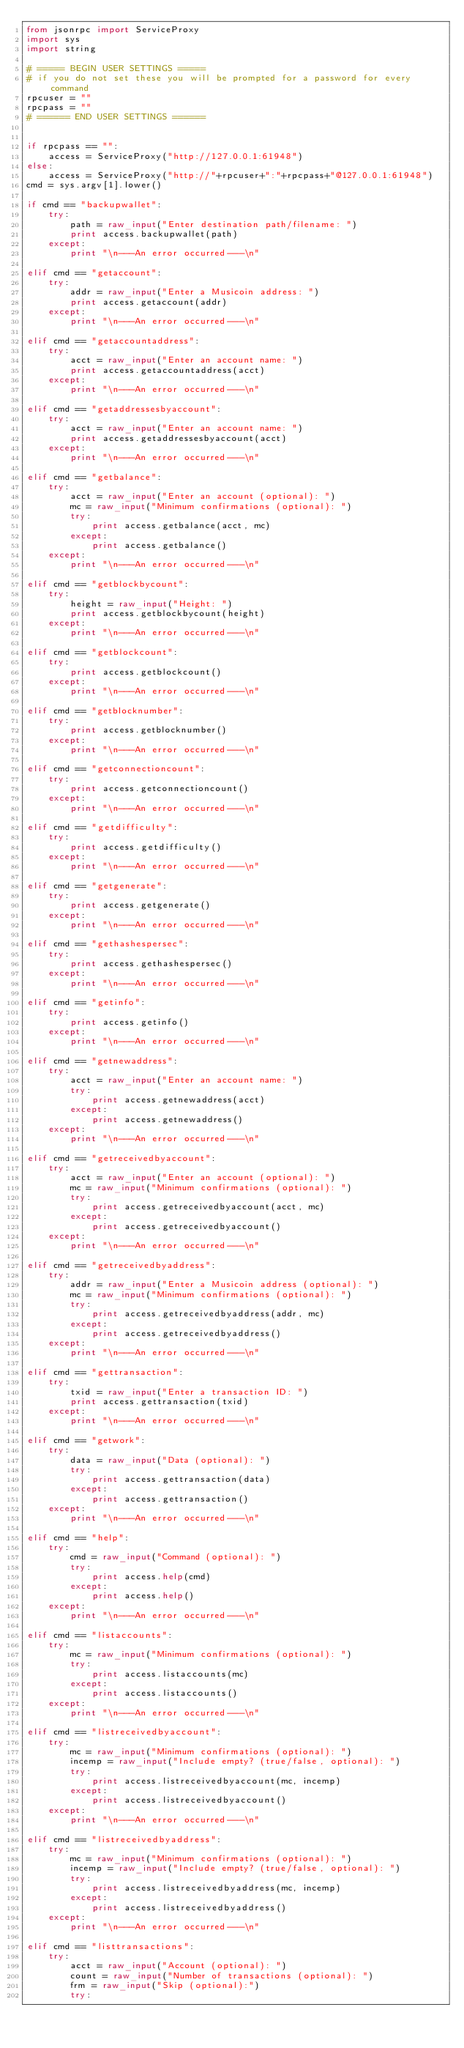Convert code to text. <code><loc_0><loc_0><loc_500><loc_500><_Python_>from jsonrpc import ServiceProxy
import sys
import string

# ===== BEGIN USER SETTINGS =====
# if you do not set these you will be prompted for a password for every command
rpcuser = ""
rpcpass = ""
# ====== END USER SETTINGS ======


if rpcpass == "":
	access = ServiceProxy("http://127.0.0.1:61948")
else:
	access = ServiceProxy("http://"+rpcuser+":"+rpcpass+"@127.0.0.1:61948")
cmd = sys.argv[1].lower()

if cmd == "backupwallet":
	try:
		path = raw_input("Enter destination path/filename: ")
		print access.backupwallet(path)
	except:
		print "\n---An error occurred---\n"

elif cmd == "getaccount":
	try:
		addr = raw_input("Enter a Musicoin address: ")
		print access.getaccount(addr)
	except:
		print "\n---An error occurred---\n"

elif cmd == "getaccountaddress":
	try:
		acct = raw_input("Enter an account name: ")
		print access.getaccountaddress(acct)
	except:
		print "\n---An error occurred---\n"

elif cmd == "getaddressesbyaccount":
	try:
		acct = raw_input("Enter an account name: ")
		print access.getaddressesbyaccount(acct)
	except:
		print "\n---An error occurred---\n"

elif cmd == "getbalance":
	try:
		acct = raw_input("Enter an account (optional): ")
		mc = raw_input("Minimum confirmations (optional): ")
		try:
			print access.getbalance(acct, mc)
		except:
			print access.getbalance()
	except:
		print "\n---An error occurred---\n"

elif cmd == "getblockbycount":
	try:
		height = raw_input("Height: ")
		print access.getblockbycount(height)
	except:
		print "\n---An error occurred---\n"

elif cmd == "getblockcount":
	try:
		print access.getblockcount()
	except:
		print "\n---An error occurred---\n"

elif cmd == "getblocknumber":
	try:
		print access.getblocknumber()
	except:
		print "\n---An error occurred---\n"

elif cmd == "getconnectioncount":
	try:
		print access.getconnectioncount()
	except:
		print "\n---An error occurred---\n"

elif cmd == "getdifficulty":
	try:
		print access.getdifficulty()
	except:
		print "\n---An error occurred---\n"

elif cmd == "getgenerate":
	try:
		print access.getgenerate()
	except:
		print "\n---An error occurred---\n"

elif cmd == "gethashespersec":
	try:
		print access.gethashespersec()
	except:
		print "\n---An error occurred---\n"

elif cmd == "getinfo":
	try:
		print access.getinfo()
	except:
		print "\n---An error occurred---\n"

elif cmd == "getnewaddress":
	try:
		acct = raw_input("Enter an account name: ")
		try:
			print access.getnewaddress(acct)
		except:
			print access.getnewaddress()
	except:
		print "\n---An error occurred---\n"

elif cmd == "getreceivedbyaccount":
	try:
		acct = raw_input("Enter an account (optional): ")
		mc = raw_input("Minimum confirmations (optional): ")
		try:
			print access.getreceivedbyaccount(acct, mc)
		except:
			print access.getreceivedbyaccount()
	except:
		print "\n---An error occurred---\n"

elif cmd == "getreceivedbyaddress":
	try:
		addr = raw_input("Enter a Musicoin address (optional): ")
		mc = raw_input("Minimum confirmations (optional): ")
		try:
			print access.getreceivedbyaddress(addr, mc)
		except:
			print access.getreceivedbyaddress()
	except:
		print "\n---An error occurred---\n"

elif cmd == "gettransaction":
	try:
		txid = raw_input("Enter a transaction ID: ")
		print access.gettransaction(txid)
	except:
		print "\n---An error occurred---\n"

elif cmd == "getwork":
	try:
		data = raw_input("Data (optional): ")
		try:
			print access.gettransaction(data)
		except:
			print access.gettransaction()
	except:
		print "\n---An error occurred---\n"

elif cmd == "help":
	try:
		cmd = raw_input("Command (optional): ")
		try:
			print access.help(cmd)
		except:
			print access.help()
	except:
		print "\n---An error occurred---\n"

elif cmd == "listaccounts":
	try:
		mc = raw_input("Minimum confirmations (optional): ")
		try:
			print access.listaccounts(mc)
		except:
			print access.listaccounts()
	except:
		print "\n---An error occurred---\n"

elif cmd == "listreceivedbyaccount":
	try:
		mc = raw_input("Minimum confirmations (optional): ")
		incemp = raw_input("Include empty? (true/false, optional): ")
		try:
			print access.listreceivedbyaccount(mc, incemp)
		except:
			print access.listreceivedbyaccount()
	except:
		print "\n---An error occurred---\n"

elif cmd == "listreceivedbyaddress":
	try:
		mc = raw_input("Minimum confirmations (optional): ")
		incemp = raw_input("Include empty? (true/false, optional): ")
		try:
			print access.listreceivedbyaddress(mc, incemp)
		except:
			print access.listreceivedbyaddress()
	except:
		print "\n---An error occurred---\n"

elif cmd == "listtransactions":
	try:
		acct = raw_input("Account (optional): ")
		count = raw_input("Number of transactions (optional): ")
		frm = raw_input("Skip (optional):")
		try:</code> 